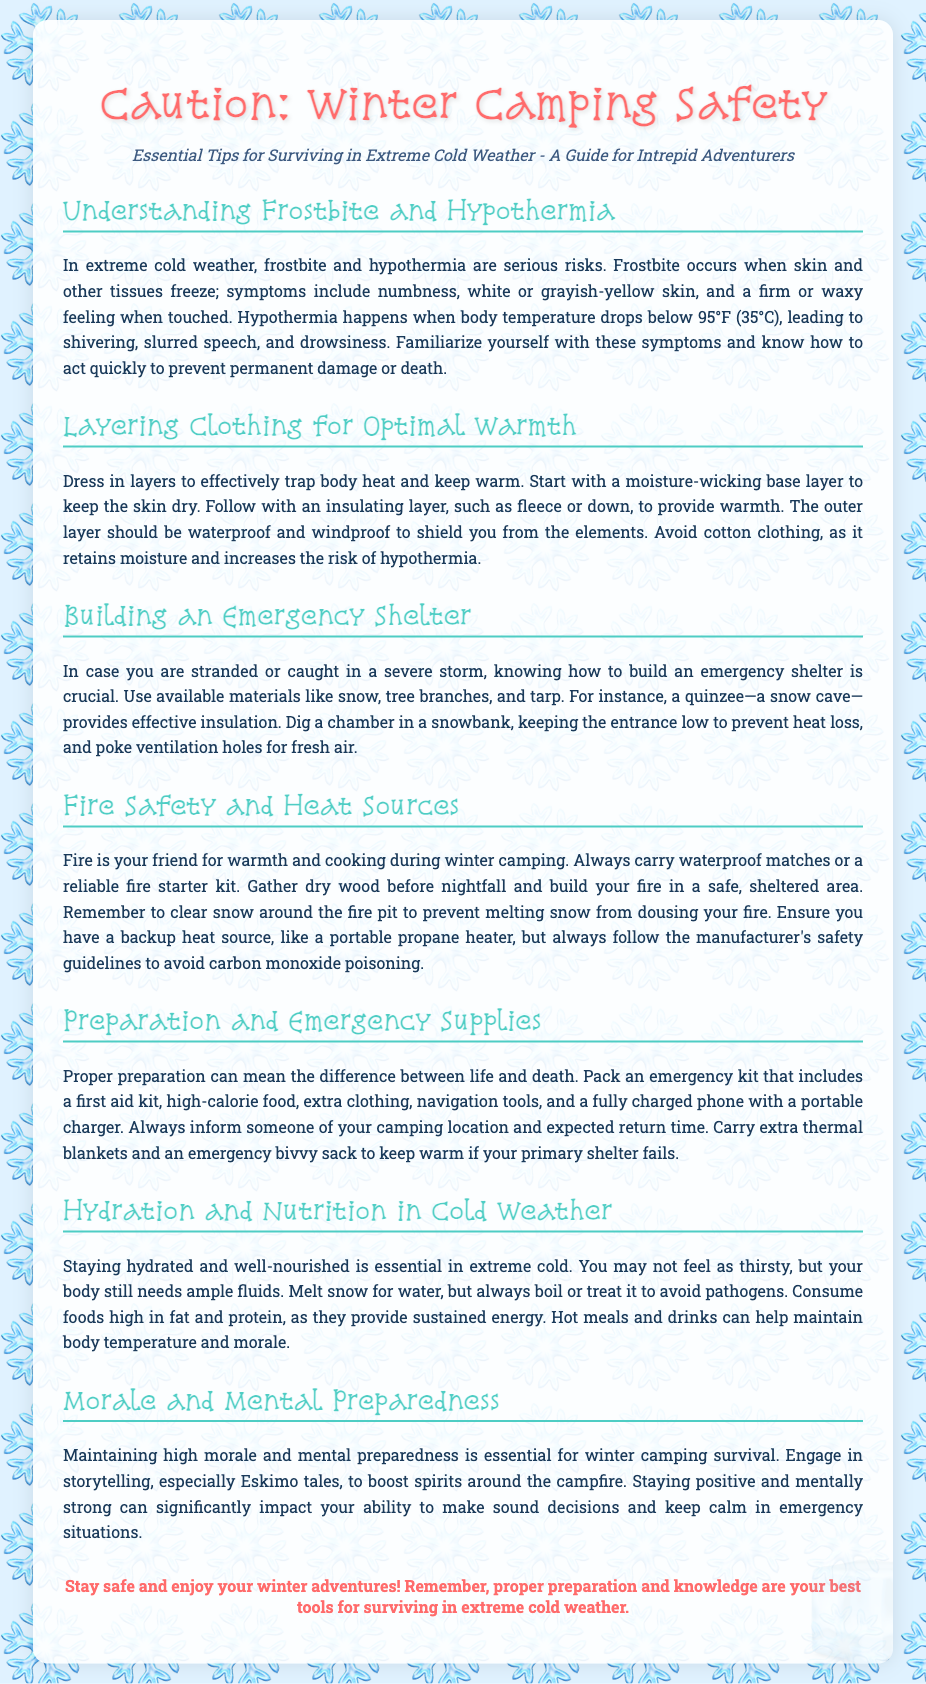What are the serious risks in extreme cold weather? The document states that frostbite and hypothermia are serious risks in extreme cold weather.
Answer: frostbite and hypothermia What is the recommended first layer for clothing? The document advises starting with a moisture-wicking base layer to keep the skin dry.
Answer: moisture-wicking base layer What should you carry for fire safety? The document mentions always carrying waterproof matches or a reliable fire starter kit for fire safety.
Answer: waterproof matches What should you inform someone about before camping? The document states that you should inform someone of your camping location and expected return time.
Answer: camping location and expected return time What is essential for maintaining morale during winter camping? Engaging in storytelling, especially Eskimo tales, is essential for maintaining morale during winter camping.
Answer: storytelling What is a quinzee? A quinzee is described in the document as a snow cave that provides effective insulation.
Answer: snow cave What should be included in an emergency kit? The document lists a first aid kit, high-calorie food, extra clothing, navigation tools, and a fully charged phone among the emergency kit contents.
Answer: first aid kit, high-calorie food, extra clothing, navigation tools, and a fully charged phone What is the body temperature threshold for hypothermia? The document states that hypothermia occurs when body temperature drops below 95°F (35°C).
Answer: 95°F (35°C) What food types provide sustained energy in cold weather? The document specifies that foods high in fat and protein provide sustained energy in cold weather.
Answer: foods high in fat and protein 